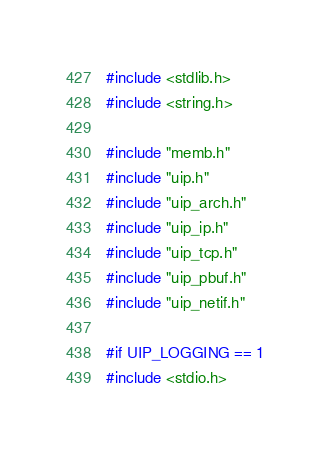<code> <loc_0><loc_0><loc_500><loc_500><_C_>#include <stdlib.h>
#include <string.h>

#include "memb.h"
#include "uip.h"
#include "uip_arch.h"
#include "uip_ip.h"
#include "uip_tcp.h"
#include "uip_pbuf.h"
#include "uip_netif.h"

#if UIP_LOGGING == 1
#include <stdio.h></code> 